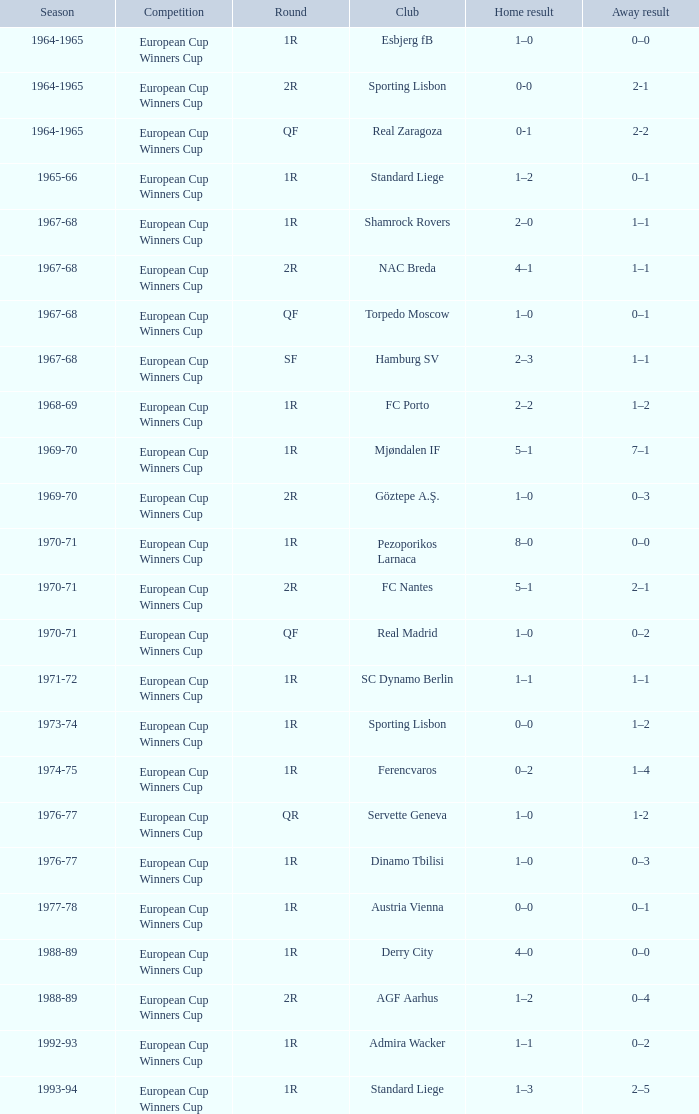In which season does a 1-2 away score happen? 1976-77. 